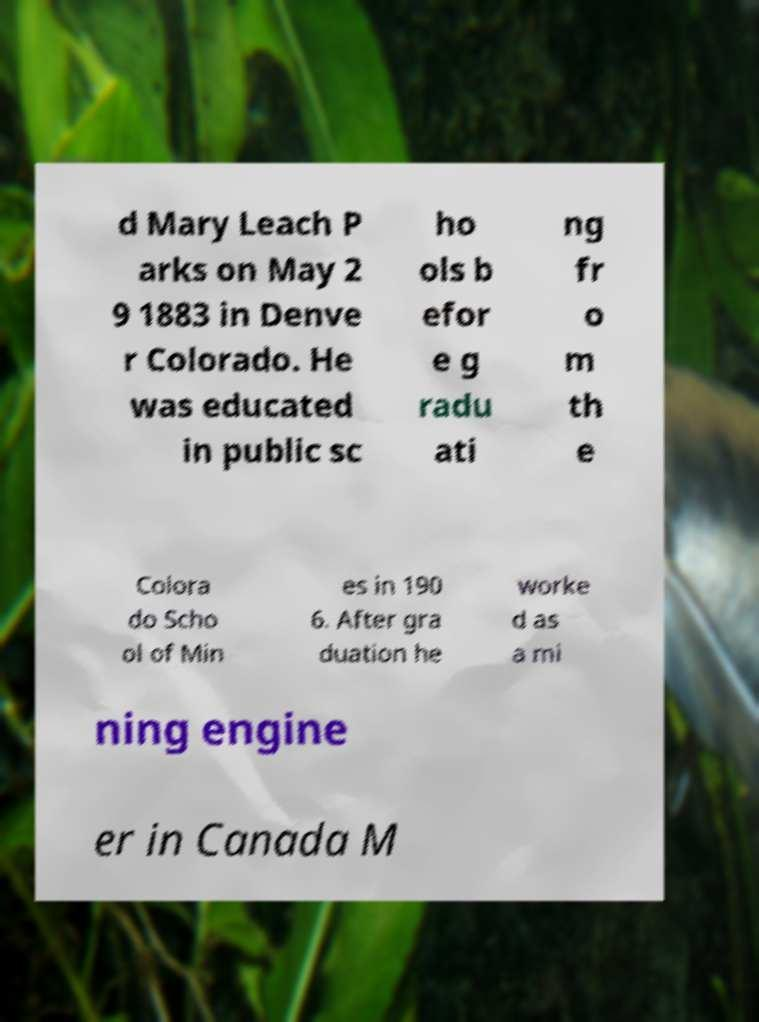I need the written content from this picture converted into text. Can you do that? d Mary Leach P arks on May 2 9 1883 in Denve r Colorado. He was educated in public sc ho ols b efor e g radu ati ng fr o m th e Colora do Scho ol of Min es in 190 6. After gra duation he worke d as a mi ning engine er in Canada M 